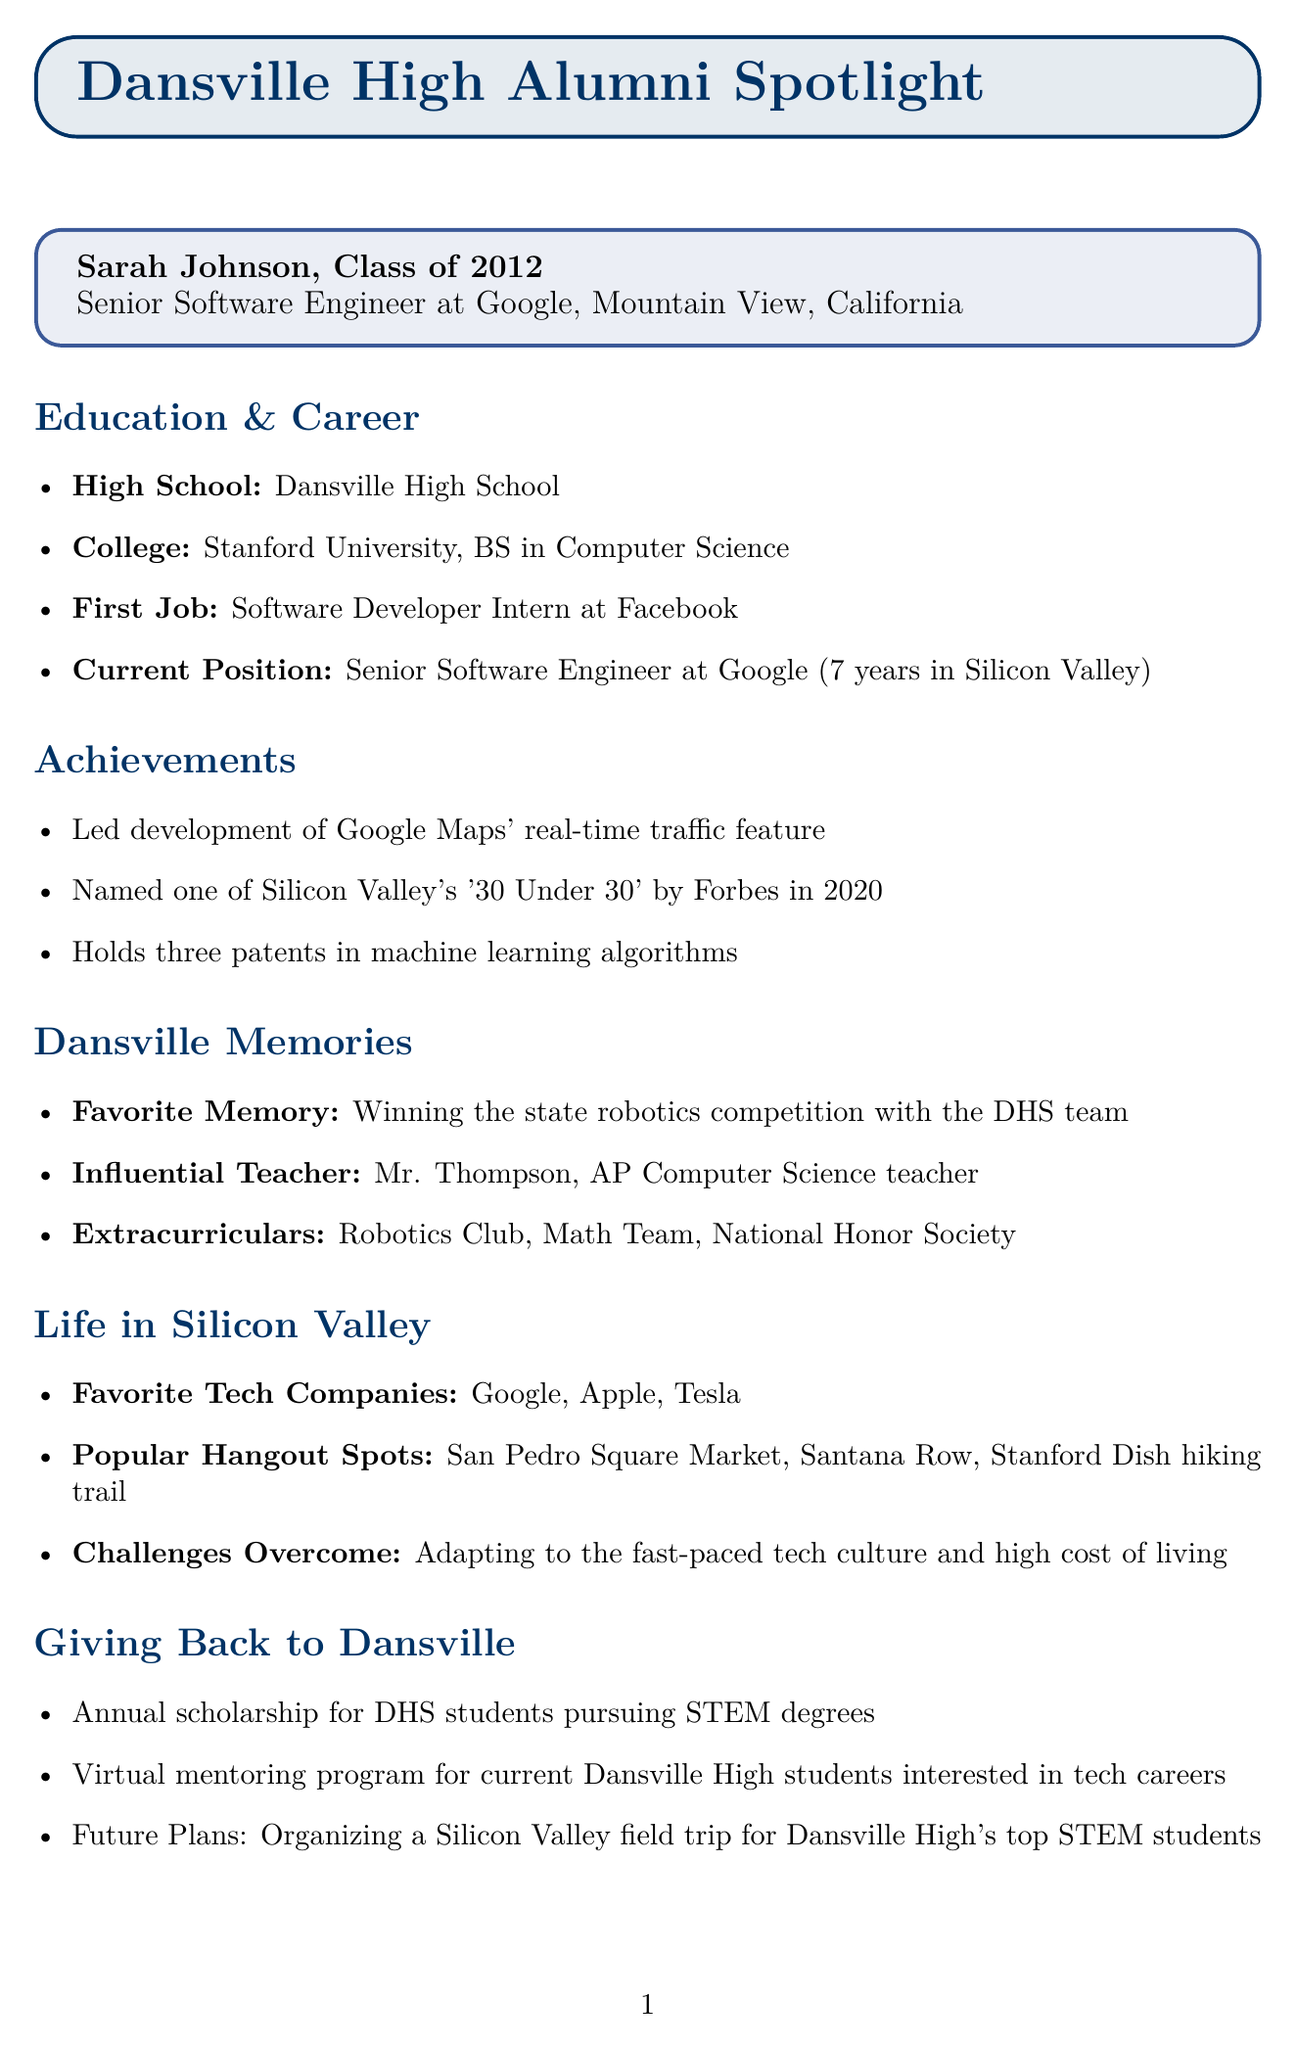What is Sarah's current job title? The document states that Sarah is a Senior Software Engineer at Google.
Answer: Senior Software Engineer Which company did Sarah work for as her first job? The document mentions that Sarah's first job was as a Software Developer Intern at Facebook.
Answer: Facebook In which year did Sarah graduate from Dansville High School? Sarah graduated from Dansville High School in the year 2012.
Answer: 2012 What is one of Sarah's significant achievements? The document lists several achievements, one of which is leading the development of Google Maps' real-time traffic feature.
Answer: Led development of Google Maps' real-time traffic feature Who was Sarah's influential teacher at Dansville High School? The document states that Mr. Thompson, the AP Computer Science teacher, was Sarah's influential teacher.
Answer: Mr. Thompson What advice does Sarah give to current students? Sarah advises students to dream big and pursue opportunities outside their comfort zone.
Answer: Don't be afraid to dream big How many years has Sarah been working in Silicon Valley? The document indicates that Sarah has been in Silicon Valley for 7 years.
Answer: 7 What scholarship initiative does Sarah support for Dansville students? The document mentions that Sarah supports an annual scholarship for DHS students pursuing STEM degrees.
Answer: Annual scholarship for DHS students pursuing STEM degrees What is a popular hangout spot mentioned by Sarah? One of the popular hangout spots Sarah mentions is the San Pedro Square Market.
Answer: San Pedro Square Market 